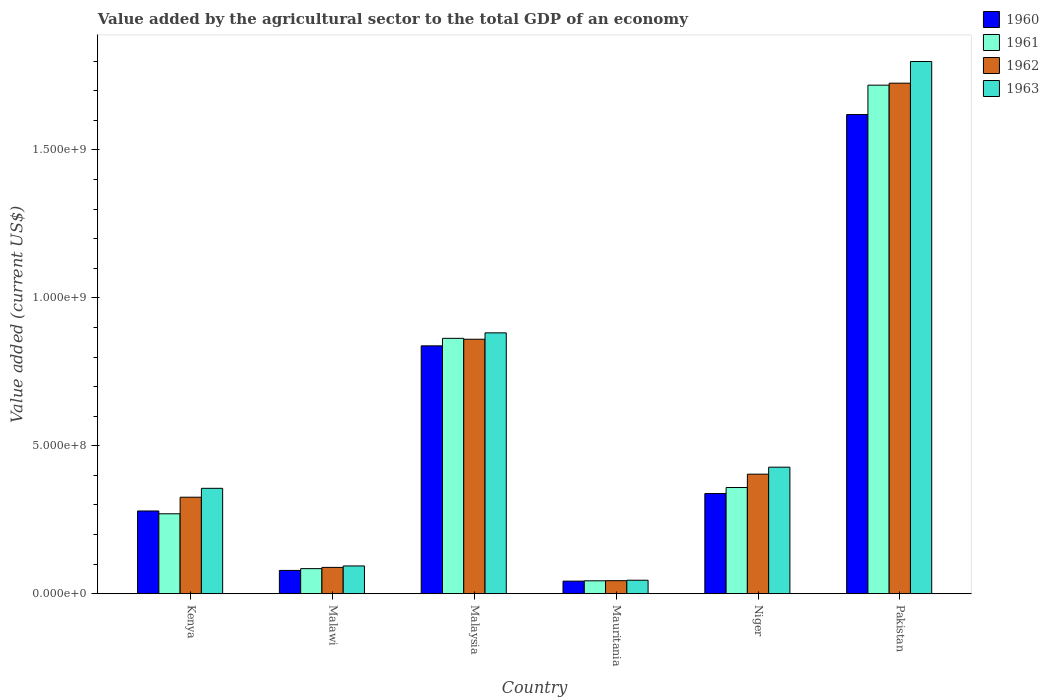How many groups of bars are there?
Your answer should be compact. 6. How many bars are there on the 6th tick from the left?
Provide a short and direct response. 4. What is the label of the 5th group of bars from the left?
Provide a short and direct response. Niger. In how many cases, is the number of bars for a given country not equal to the number of legend labels?
Your answer should be very brief. 0. What is the value added by the agricultural sector to the total GDP in 1960 in Malaysia?
Keep it short and to the point. 8.38e+08. Across all countries, what is the maximum value added by the agricultural sector to the total GDP in 1962?
Offer a terse response. 1.73e+09. Across all countries, what is the minimum value added by the agricultural sector to the total GDP in 1963?
Ensure brevity in your answer.  4.57e+07. In which country was the value added by the agricultural sector to the total GDP in 1962 minimum?
Provide a succinct answer. Mauritania. What is the total value added by the agricultural sector to the total GDP in 1963 in the graph?
Provide a succinct answer. 3.60e+09. What is the difference between the value added by the agricultural sector to the total GDP in 1963 in Kenya and that in Malaysia?
Your answer should be compact. -5.25e+08. What is the difference between the value added by the agricultural sector to the total GDP in 1963 in Malawi and the value added by the agricultural sector to the total GDP in 1961 in Malaysia?
Offer a very short reply. -7.69e+08. What is the average value added by the agricultural sector to the total GDP in 1962 per country?
Provide a succinct answer. 5.75e+08. What is the difference between the value added by the agricultural sector to the total GDP of/in 1963 and value added by the agricultural sector to the total GDP of/in 1961 in Niger?
Give a very brief answer. 6.88e+07. What is the ratio of the value added by the agricultural sector to the total GDP in 1960 in Malawi to that in Malaysia?
Ensure brevity in your answer.  0.09. Is the difference between the value added by the agricultural sector to the total GDP in 1963 in Kenya and Malaysia greater than the difference between the value added by the agricultural sector to the total GDP in 1961 in Kenya and Malaysia?
Offer a very short reply. Yes. What is the difference between the highest and the second highest value added by the agricultural sector to the total GDP in 1960?
Provide a short and direct response. -1.28e+09. What is the difference between the highest and the lowest value added by the agricultural sector to the total GDP in 1960?
Your answer should be compact. 1.58e+09. Is it the case that in every country, the sum of the value added by the agricultural sector to the total GDP in 1961 and value added by the agricultural sector to the total GDP in 1962 is greater than the sum of value added by the agricultural sector to the total GDP in 1963 and value added by the agricultural sector to the total GDP in 1960?
Your answer should be very brief. No. What does the 4th bar from the left in Mauritania represents?
Provide a short and direct response. 1963. What does the 1st bar from the right in Malaysia represents?
Your answer should be compact. 1963. Are the values on the major ticks of Y-axis written in scientific E-notation?
Keep it short and to the point. Yes. Does the graph contain any zero values?
Offer a terse response. No. Does the graph contain grids?
Offer a terse response. No. How many legend labels are there?
Your answer should be compact. 4. What is the title of the graph?
Make the answer very short. Value added by the agricultural sector to the total GDP of an economy. Does "1982" appear as one of the legend labels in the graph?
Ensure brevity in your answer.  No. What is the label or title of the X-axis?
Offer a very short reply. Country. What is the label or title of the Y-axis?
Give a very brief answer. Value added (current US$). What is the Value added (current US$) of 1960 in Kenya?
Give a very brief answer. 2.80e+08. What is the Value added (current US$) of 1961 in Kenya?
Offer a terse response. 2.70e+08. What is the Value added (current US$) in 1962 in Kenya?
Offer a terse response. 3.26e+08. What is the Value added (current US$) of 1963 in Kenya?
Offer a very short reply. 3.56e+08. What is the Value added (current US$) in 1960 in Malawi?
Offer a very short reply. 7.88e+07. What is the Value added (current US$) of 1961 in Malawi?
Ensure brevity in your answer.  8.48e+07. What is the Value added (current US$) in 1962 in Malawi?
Your answer should be compact. 8.90e+07. What is the Value added (current US$) in 1963 in Malawi?
Keep it short and to the point. 9.39e+07. What is the Value added (current US$) of 1960 in Malaysia?
Keep it short and to the point. 8.38e+08. What is the Value added (current US$) in 1961 in Malaysia?
Offer a very short reply. 8.63e+08. What is the Value added (current US$) in 1962 in Malaysia?
Your answer should be compact. 8.60e+08. What is the Value added (current US$) in 1963 in Malaysia?
Your response must be concise. 8.82e+08. What is the Value added (current US$) in 1960 in Mauritania?
Ensure brevity in your answer.  4.26e+07. What is the Value added (current US$) in 1961 in Mauritania?
Ensure brevity in your answer.  4.37e+07. What is the Value added (current US$) in 1962 in Mauritania?
Provide a short and direct response. 4.41e+07. What is the Value added (current US$) in 1963 in Mauritania?
Make the answer very short. 4.57e+07. What is the Value added (current US$) in 1960 in Niger?
Ensure brevity in your answer.  3.39e+08. What is the Value added (current US$) of 1961 in Niger?
Offer a very short reply. 3.59e+08. What is the Value added (current US$) of 1962 in Niger?
Provide a succinct answer. 4.04e+08. What is the Value added (current US$) of 1963 in Niger?
Offer a terse response. 4.28e+08. What is the Value added (current US$) in 1960 in Pakistan?
Your response must be concise. 1.62e+09. What is the Value added (current US$) in 1961 in Pakistan?
Your answer should be very brief. 1.72e+09. What is the Value added (current US$) in 1962 in Pakistan?
Offer a terse response. 1.73e+09. What is the Value added (current US$) in 1963 in Pakistan?
Ensure brevity in your answer.  1.80e+09. Across all countries, what is the maximum Value added (current US$) of 1960?
Provide a succinct answer. 1.62e+09. Across all countries, what is the maximum Value added (current US$) of 1961?
Make the answer very short. 1.72e+09. Across all countries, what is the maximum Value added (current US$) of 1962?
Your answer should be compact. 1.73e+09. Across all countries, what is the maximum Value added (current US$) in 1963?
Give a very brief answer. 1.80e+09. Across all countries, what is the minimum Value added (current US$) in 1960?
Provide a succinct answer. 4.26e+07. Across all countries, what is the minimum Value added (current US$) in 1961?
Offer a very short reply. 4.37e+07. Across all countries, what is the minimum Value added (current US$) of 1962?
Your answer should be compact. 4.41e+07. Across all countries, what is the minimum Value added (current US$) of 1963?
Your answer should be compact. 4.57e+07. What is the total Value added (current US$) in 1960 in the graph?
Your response must be concise. 3.20e+09. What is the total Value added (current US$) in 1961 in the graph?
Give a very brief answer. 3.34e+09. What is the total Value added (current US$) in 1962 in the graph?
Make the answer very short. 3.45e+09. What is the total Value added (current US$) of 1963 in the graph?
Ensure brevity in your answer.  3.60e+09. What is the difference between the Value added (current US$) in 1960 in Kenya and that in Malawi?
Your answer should be compact. 2.01e+08. What is the difference between the Value added (current US$) in 1961 in Kenya and that in Malawi?
Provide a succinct answer. 1.85e+08. What is the difference between the Value added (current US$) of 1962 in Kenya and that in Malawi?
Offer a very short reply. 2.37e+08. What is the difference between the Value added (current US$) in 1963 in Kenya and that in Malawi?
Your answer should be very brief. 2.62e+08. What is the difference between the Value added (current US$) in 1960 in Kenya and that in Malaysia?
Your answer should be very brief. -5.58e+08. What is the difference between the Value added (current US$) of 1961 in Kenya and that in Malaysia?
Keep it short and to the point. -5.93e+08. What is the difference between the Value added (current US$) in 1962 in Kenya and that in Malaysia?
Ensure brevity in your answer.  -5.34e+08. What is the difference between the Value added (current US$) of 1963 in Kenya and that in Malaysia?
Provide a short and direct response. -5.25e+08. What is the difference between the Value added (current US$) in 1960 in Kenya and that in Mauritania?
Make the answer very short. 2.37e+08. What is the difference between the Value added (current US$) in 1961 in Kenya and that in Mauritania?
Give a very brief answer. 2.26e+08. What is the difference between the Value added (current US$) of 1962 in Kenya and that in Mauritania?
Provide a succinct answer. 2.82e+08. What is the difference between the Value added (current US$) of 1963 in Kenya and that in Mauritania?
Your answer should be very brief. 3.11e+08. What is the difference between the Value added (current US$) in 1960 in Kenya and that in Niger?
Offer a terse response. -5.89e+07. What is the difference between the Value added (current US$) of 1961 in Kenya and that in Niger?
Offer a terse response. -8.87e+07. What is the difference between the Value added (current US$) of 1962 in Kenya and that in Niger?
Keep it short and to the point. -7.79e+07. What is the difference between the Value added (current US$) in 1963 in Kenya and that in Niger?
Make the answer very short. -7.14e+07. What is the difference between the Value added (current US$) of 1960 in Kenya and that in Pakistan?
Ensure brevity in your answer.  -1.34e+09. What is the difference between the Value added (current US$) in 1961 in Kenya and that in Pakistan?
Make the answer very short. -1.45e+09. What is the difference between the Value added (current US$) in 1962 in Kenya and that in Pakistan?
Your answer should be compact. -1.40e+09. What is the difference between the Value added (current US$) in 1963 in Kenya and that in Pakistan?
Give a very brief answer. -1.44e+09. What is the difference between the Value added (current US$) in 1960 in Malawi and that in Malaysia?
Offer a very short reply. -7.59e+08. What is the difference between the Value added (current US$) of 1961 in Malawi and that in Malaysia?
Offer a terse response. -7.78e+08. What is the difference between the Value added (current US$) in 1962 in Malawi and that in Malaysia?
Offer a very short reply. -7.71e+08. What is the difference between the Value added (current US$) in 1963 in Malawi and that in Malaysia?
Keep it short and to the point. -7.88e+08. What is the difference between the Value added (current US$) of 1960 in Malawi and that in Mauritania?
Provide a succinct answer. 3.62e+07. What is the difference between the Value added (current US$) in 1961 in Malawi and that in Mauritania?
Make the answer very short. 4.11e+07. What is the difference between the Value added (current US$) in 1962 in Malawi and that in Mauritania?
Your answer should be compact. 4.49e+07. What is the difference between the Value added (current US$) of 1963 in Malawi and that in Mauritania?
Make the answer very short. 4.83e+07. What is the difference between the Value added (current US$) in 1960 in Malawi and that in Niger?
Your answer should be very brief. -2.60e+08. What is the difference between the Value added (current US$) of 1961 in Malawi and that in Niger?
Give a very brief answer. -2.74e+08. What is the difference between the Value added (current US$) in 1962 in Malawi and that in Niger?
Your answer should be compact. -3.15e+08. What is the difference between the Value added (current US$) of 1963 in Malawi and that in Niger?
Provide a short and direct response. -3.34e+08. What is the difference between the Value added (current US$) in 1960 in Malawi and that in Pakistan?
Make the answer very short. -1.54e+09. What is the difference between the Value added (current US$) in 1961 in Malawi and that in Pakistan?
Offer a terse response. -1.63e+09. What is the difference between the Value added (current US$) in 1962 in Malawi and that in Pakistan?
Ensure brevity in your answer.  -1.64e+09. What is the difference between the Value added (current US$) in 1963 in Malawi and that in Pakistan?
Provide a succinct answer. -1.70e+09. What is the difference between the Value added (current US$) of 1960 in Malaysia and that in Mauritania?
Your answer should be compact. 7.95e+08. What is the difference between the Value added (current US$) in 1961 in Malaysia and that in Mauritania?
Your answer should be very brief. 8.19e+08. What is the difference between the Value added (current US$) in 1962 in Malaysia and that in Mauritania?
Your response must be concise. 8.16e+08. What is the difference between the Value added (current US$) in 1963 in Malaysia and that in Mauritania?
Your response must be concise. 8.36e+08. What is the difference between the Value added (current US$) of 1960 in Malaysia and that in Niger?
Keep it short and to the point. 4.99e+08. What is the difference between the Value added (current US$) in 1961 in Malaysia and that in Niger?
Your response must be concise. 5.04e+08. What is the difference between the Value added (current US$) of 1962 in Malaysia and that in Niger?
Your answer should be compact. 4.56e+08. What is the difference between the Value added (current US$) of 1963 in Malaysia and that in Niger?
Offer a very short reply. 4.54e+08. What is the difference between the Value added (current US$) of 1960 in Malaysia and that in Pakistan?
Your answer should be very brief. -7.82e+08. What is the difference between the Value added (current US$) in 1961 in Malaysia and that in Pakistan?
Provide a short and direct response. -8.56e+08. What is the difference between the Value added (current US$) in 1962 in Malaysia and that in Pakistan?
Your answer should be compact. -8.65e+08. What is the difference between the Value added (current US$) of 1963 in Malaysia and that in Pakistan?
Keep it short and to the point. -9.17e+08. What is the difference between the Value added (current US$) of 1960 in Mauritania and that in Niger?
Provide a succinct answer. -2.96e+08. What is the difference between the Value added (current US$) of 1961 in Mauritania and that in Niger?
Ensure brevity in your answer.  -3.15e+08. What is the difference between the Value added (current US$) in 1962 in Mauritania and that in Niger?
Give a very brief answer. -3.60e+08. What is the difference between the Value added (current US$) in 1963 in Mauritania and that in Niger?
Provide a short and direct response. -3.82e+08. What is the difference between the Value added (current US$) of 1960 in Mauritania and that in Pakistan?
Your response must be concise. -1.58e+09. What is the difference between the Value added (current US$) of 1961 in Mauritania and that in Pakistan?
Offer a very short reply. -1.67e+09. What is the difference between the Value added (current US$) in 1962 in Mauritania and that in Pakistan?
Make the answer very short. -1.68e+09. What is the difference between the Value added (current US$) of 1963 in Mauritania and that in Pakistan?
Give a very brief answer. -1.75e+09. What is the difference between the Value added (current US$) of 1960 in Niger and that in Pakistan?
Ensure brevity in your answer.  -1.28e+09. What is the difference between the Value added (current US$) of 1961 in Niger and that in Pakistan?
Offer a very short reply. -1.36e+09. What is the difference between the Value added (current US$) of 1962 in Niger and that in Pakistan?
Provide a succinct answer. -1.32e+09. What is the difference between the Value added (current US$) of 1963 in Niger and that in Pakistan?
Make the answer very short. -1.37e+09. What is the difference between the Value added (current US$) in 1960 in Kenya and the Value added (current US$) in 1961 in Malawi?
Your answer should be very brief. 1.95e+08. What is the difference between the Value added (current US$) in 1960 in Kenya and the Value added (current US$) in 1962 in Malawi?
Your answer should be compact. 1.91e+08. What is the difference between the Value added (current US$) in 1960 in Kenya and the Value added (current US$) in 1963 in Malawi?
Your answer should be very brief. 1.86e+08. What is the difference between the Value added (current US$) in 1961 in Kenya and the Value added (current US$) in 1962 in Malawi?
Offer a terse response. 1.81e+08. What is the difference between the Value added (current US$) in 1961 in Kenya and the Value added (current US$) in 1963 in Malawi?
Give a very brief answer. 1.76e+08. What is the difference between the Value added (current US$) in 1962 in Kenya and the Value added (current US$) in 1963 in Malawi?
Offer a terse response. 2.32e+08. What is the difference between the Value added (current US$) in 1960 in Kenya and the Value added (current US$) in 1961 in Malaysia?
Provide a short and direct response. -5.83e+08. What is the difference between the Value added (current US$) in 1960 in Kenya and the Value added (current US$) in 1962 in Malaysia?
Your answer should be very brief. -5.80e+08. What is the difference between the Value added (current US$) in 1960 in Kenya and the Value added (current US$) in 1963 in Malaysia?
Give a very brief answer. -6.02e+08. What is the difference between the Value added (current US$) of 1961 in Kenya and the Value added (current US$) of 1962 in Malaysia?
Keep it short and to the point. -5.90e+08. What is the difference between the Value added (current US$) in 1961 in Kenya and the Value added (current US$) in 1963 in Malaysia?
Offer a very short reply. -6.11e+08. What is the difference between the Value added (current US$) in 1962 in Kenya and the Value added (current US$) in 1963 in Malaysia?
Provide a short and direct response. -5.55e+08. What is the difference between the Value added (current US$) in 1960 in Kenya and the Value added (current US$) in 1961 in Mauritania?
Ensure brevity in your answer.  2.36e+08. What is the difference between the Value added (current US$) of 1960 in Kenya and the Value added (current US$) of 1962 in Mauritania?
Offer a terse response. 2.36e+08. What is the difference between the Value added (current US$) of 1960 in Kenya and the Value added (current US$) of 1963 in Mauritania?
Give a very brief answer. 2.34e+08. What is the difference between the Value added (current US$) of 1961 in Kenya and the Value added (current US$) of 1962 in Mauritania?
Your answer should be very brief. 2.26e+08. What is the difference between the Value added (current US$) in 1961 in Kenya and the Value added (current US$) in 1963 in Mauritania?
Ensure brevity in your answer.  2.25e+08. What is the difference between the Value added (current US$) of 1962 in Kenya and the Value added (current US$) of 1963 in Mauritania?
Offer a terse response. 2.81e+08. What is the difference between the Value added (current US$) in 1960 in Kenya and the Value added (current US$) in 1961 in Niger?
Offer a very short reply. -7.92e+07. What is the difference between the Value added (current US$) of 1960 in Kenya and the Value added (current US$) of 1962 in Niger?
Offer a terse response. -1.24e+08. What is the difference between the Value added (current US$) of 1960 in Kenya and the Value added (current US$) of 1963 in Niger?
Your answer should be very brief. -1.48e+08. What is the difference between the Value added (current US$) in 1961 in Kenya and the Value added (current US$) in 1962 in Niger?
Provide a short and direct response. -1.34e+08. What is the difference between the Value added (current US$) of 1961 in Kenya and the Value added (current US$) of 1963 in Niger?
Keep it short and to the point. -1.58e+08. What is the difference between the Value added (current US$) in 1962 in Kenya and the Value added (current US$) in 1963 in Niger?
Your answer should be very brief. -1.02e+08. What is the difference between the Value added (current US$) of 1960 in Kenya and the Value added (current US$) of 1961 in Pakistan?
Your answer should be compact. -1.44e+09. What is the difference between the Value added (current US$) in 1960 in Kenya and the Value added (current US$) in 1962 in Pakistan?
Give a very brief answer. -1.45e+09. What is the difference between the Value added (current US$) of 1960 in Kenya and the Value added (current US$) of 1963 in Pakistan?
Keep it short and to the point. -1.52e+09. What is the difference between the Value added (current US$) in 1961 in Kenya and the Value added (current US$) in 1962 in Pakistan?
Your answer should be very brief. -1.46e+09. What is the difference between the Value added (current US$) in 1961 in Kenya and the Value added (current US$) in 1963 in Pakistan?
Your answer should be very brief. -1.53e+09. What is the difference between the Value added (current US$) in 1962 in Kenya and the Value added (current US$) in 1963 in Pakistan?
Make the answer very short. -1.47e+09. What is the difference between the Value added (current US$) of 1960 in Malawi and the Value added (current US$) of 1961 in Malaysia?
Ensure brevity in your answer.  -7.84e+08. What is the difference between the Value added (current US$) of 1960 in Malawi and the Value added (current US$) of 1962 in Malaysia?
Provide a short and direct response. -7.81e+08. What is the difference between the Value added (current US$) of 1960 in Malawi and the Value added (current US$) of 1963 in Malaysia?
Keep it short and to the point. -8.03e+08. What is the difference between the Value added (current US$) in 1961 in Malawi and the Value added (current US$) in 1962 in Malaysia?
Your answer should be very brief. -7.75e+08. What is the difference between the Value added (current US$) in 1961 in Malawi and the Value added (current US$) in 1963 in Malaysia?
Provide a succinct answer. -7.97e+08. What is the difference between the Value added (current US$) in 1962 in Malawi and the Value added (current US$) in 1963 in Malaysia?
Give a very brief answer. -7.93e+08. What is the difference between the Value added (current US$) of 1960 in Malawi and the Value added (current US$) of 1961 in Mauritania?
Provide a succinct answer. 3.51e+07. What is the difference between the Value added (current US$) in 1960 in Malawi and the Value added (current US$) in 1962 in Mauritania?
Your answer should be very brief. 3.47e+07. What is the difference between the Value added (current US$) in 1960 in Malawi and the Value added (current US$) in 1963 in Mauritania?
Offer a very short reply. 3.32e+07. What is the difference between the Value added (current US$) of 1961 in Malawi and the Value added (current US$) of 1962 in Mauritania?
Your response must be concise. 4.07e+07. What is the difference between the Value added (current US$) in 1961 in Malawi and the Value added (current US$) in 1963 in Mauritania?
Offer a terse response. 3.92e+07. What is the difference between the Value added (current US$) in 1962 in Malawi and the Value added (current US$) in 1963 in Mauritania?
Your answer should be compact. 4.34e+07. What is the difference between the Value added (current US$) of 1960 in Malawi and the Value added (current US$) of 1961 in Niger?
Make the answer very short. -2.80e+08. What is the difference between the Value added (current US$) in 1960 in Malawi and the Value added (current US$) in 1962 in Niger?
Keep it short and to the point. -3.25e+08. What is the difference between the Value added (current US$) of 1960 in Malawi and the Value added (current US$) of 1963 in Niger?
Provide a short and direct response. -3.49e+08. What is the difference between the Value added (current US$) of 1961 in Malawi and the Value added (current US$) of 1962 in Niger?
Provide a short and direct response. -3.19e+08. What is the difference between the Value added (current US$) in 1961 in Malawi and the Value added (current US$) in 1963 in Niger?
Provide a succinct answer. -3.43e+08. What is the difference between the Value added (current US$) in 1962 in Malawi and the Value added (current US$) in 1963 in Niger?
Provide a succinct answer. -3.39e+08. What is the difference between the Value added (current US$) of 1960 in Malawi and the Value added (current US$) of 1961 in Pakistan?
Provide a succinct answer. -1.64e+09. What is the difference between the Value added (current US$) in 1960 in Malawi and the Value added (current US$) in 1962 in Pakistan?
Offer a very short reply. -1.65e+09. What is the difference between the Value added (current US$) in 1960 in Malawi and the Value added (current US$) in 1963 in Pakistan?
Offer a terse response. -1.72e+09. What is the difference between the Value added (current US$) in 1961 in Malawi and the Value added (current US$) in 1962 in Pakistan?
Your answer should be very brief. -1.64e+09. What is the difference between the Value added (current US$) of 1961 in Malawi and the Value added (current US$) of 1963 in Pakistan?
Your response must be concise. -1.71e+09. What is the difference between the Value added (current US$) in 1962 in Malawi and the Value added (current US$) in 1963 in Pakistan?
Provide a succinct answer. -1.71e+09. What is the difference between the Value added (current US$) in 1960 in Malaysia and the Value added (current US$) in 1961 in Mauritania?
Your response must be concise. 7.94e+08. What is the difference between the Value added (current US$) of 1960 in Malaysia and the Value added (current US$) of 1962 in Mauritania?
Make the answer very short. 7.94e+08. What is the difference between the Value added (current US$) in 1960 in Malaysia and the Value added (current US$) in 1963 in Mauritania?
Provide a succinct answer. 7.92e+08. What is the difference between the Value added (current US$) of 1961 in Malaysia and the Value added (current US$) of 1962 in Mauritania?
Provide a short and direct response. 8.19e+08. What is the difference between the Value added (current US$) of 1961 in Malaysia and the Value added (current US$) of 1963 in Mauritania?
Give a very brief answer. 8.17e+08. What is the difference between the Value added (current US$) of 1962 in Malaysia and the Value added (current US$) of 1963 in Mauritania?
Ensure brevity in your answer.  8.14e+08. What is the difference between the Value added (current US$) in 1960 in Malaysia and the Value added (current US$) in 1961 in Niger?
Make the answer very short. 4.79e+08. What is the difference between the Value added (current US$) of 1960 in Malaysia and the Value added (current US$) of 1962 in Niger?
Keep it short and to the point. 4.34e+08. What is the difference between the Value added (current US$) in 1960 in Malaysia and the Value added (current US$) in 1963 in Niger?
Your answer should be very brief. 4.10e+08. What is the difference between the Value added (current US$) in 1961 in Malaysia and the Value added (current US$) in 1962 in Niger?
Your answer should be compact. 4.59e+08. What is the difference between the Value added (current US$) of 1961 in Malaysia and the Value added (current US$) of 1963 in Niger?
Ensure brevity in your answer.  4.35e+08. What is the difference between the Value added (current US$) of 1962 in Malaysia and the Value added (current US$) of 1963 in Niger?
Offer a very short reply. 4.32e+08. What is the difference between the Value added (current US$) in 1960 in Malaysia and the Value added (current US$) in 1961 in Pakistan?
Your response must be concise. -8.81e+08. What is the difference between the Value added (current US$) of 1960 in Malaysia and the Value added (current US$) of 1962 in Pakistan?
Ensure brevity in your answer.  -8.88e+08. What is the difference between the Value added (current US$) in 1960 in Malaysia and the Value added (current US$) in 1963 in Pakistan?
Provide a short and direct response. -9.61e+08. What is the difference between the Value added (current US$) of 1961 in Malaysia and the Value added (current US$) of 1962 in Pakistan?
Keep it short and to the point. -8.62e+08. What is the difference between the Value added (current US$) in 1961 in Malaysia and the Value added (current US$) in 1963 in Pakistan?
Offer a very short reply. -9.36e+08. What is the difference between the Value added (current US$) of 1962 in Malaysia and the Value added (current US$) of 1963 in Pakistan?
Ensure brevity in your answer.  -9.39e+08. What is the difference between the Value added (current US$) of 1960 in Mauritania and the Value added (current US$) of 1961 in Niger?
Ensure brevity in your answer.  -3.16e+08. What is the difference between the Value added (current US$) of 1960 in Mauritania and the Value added (current US$) of 1962 in Niger?
Your response must be concise. -3.62e+08. What is the difference between the Value added (current US$) in 1960 in Mauritania and the Value added (current US$) in 1963 in Niger?
Your response must be concise. -3.85e+08. What is the difference between the Value added (current US$) in 1961 in Mauritania and the Value added (current US$) in 1962 in Niger?
Your response must be concise. -3.60e+08. What is the difference between the Value added (current US$) of 1961 in Mauritania and the Value added (current US$) of 1963 in Niger?
Keep it short and to the point. -3.84e+08. What is the difference between the Value added (current US$) in 1962 in Mauritania and the Value added (current US$) in 1963 in Niger?
Your response must be concise. -3.84e+08. What is the difference between the Value added (current US$) of 1960 in Mauritania and the Value added (current US$) of 1961 in Pakistan?
Provide a succinct answer. -1.68e+09. What is the difference between the Value added (current US$) in 1960 in Mauritania and the Value added (current US$) in 1962 in Pakistan?
Keep it short and to the point. -1.68e+09. What is the difference between the Value added (current US$) of 1960 in Mauritania and the Value added (current US$) of 1963 in Pakistan?
Keep it short and to the point. -1.76e+09. What is the difference between the Value added (current US$) of 1961 in Mauritania and the Value added (current US$) of 1962 in Pakistan?
Provide a short and direct response. -1.68e+09. What is the difference between the Value added (current US$) of 1961 in Mauritania and the Value added (current US$) of 1963 in Pakistan?
Your response must be concise. -1.75e+09. What is the difference between the Value added (current US$) in 1962 in Mauritania and the Value added (current US$) in 1963 in Pakistan?
Make the answer very short. -1.75e+09. What is the difference between the Value added (current US$) of 1960 in Niger and the Value added (current US$) of 1961 in Pakistan?
Provide a short and direct response. -1.38e+09. What is the difference between the Value added (current US$) of 1960 in Niger and the Value added (current US$) of 1962 in Pakistan?
Provide a short and direct response. -1.39e+09. What is the difference between the Value added (current US$) of 1960 in Niger and the Value added (current US$) of 1963 in Pakistan?
Make the answer very short. -1.46e+09. What is the difference between the Value added (current US$) of 1961 in Niger and the Value added (current US$) of 1962 in Pakistan?
Your answer should be compact. -1.37e+09. What is the difference between the Value added (current US$) of 1961 in Niger and the Value added (current US$) of 1963 in Pakistan?
Offer a very short reply. -1.44e+09. What is the difference between the Value added (current US$) of 1962 in Niger and the Value added (current US$) of 1963 in Pakistan?
Provide a short and direct response. -1.39e+09. What is the average Value added (current US$) of 1960 per country?
Ensure brevity in your answer.  5.33e+08. What is the average Value added (current US$) of 1961 per country?
Your answer should be very brief. 5.57e+08. What is the average Value added (current US$) in 1962 per country?
Ensure brevity in your answer.  5.75e+08. What is the average Value added (current US$) of 1963 per country?
Keep it short and to the point. 6.01e+08. What is the difference between the Value added (current US$) of 1960 and Value added (current US$) of 1961 in Kenya?
Provide a succinct answer. 9.51e+06. What is the difference between the Value added (current US$) in 1960 and Value added (current US$) in 1962 in Kenya?
Your answer should be compact. -4.65e+07. What is the difference between the Value added (current US$) of 1960 and Value added (current US$) of 1963 in Kenya?
Your answer should be very brief. -7.66e+07. What is the difference between the Value added (current US$) in 1961 and Value added (current US$) in 1962 in Kenya?
Your answer should be compact. -5.60e+07. What is the difference between the Value added (current US$) in 1961 and Value added (current US$) in 1963 in Kenya?
Ensure brevity in your answer.  -8.61e+07. What is the difference between the Value added (current US$) of 1962 and Value added (current US$) of 1963 in Kenya?
Offer a very short reply. -3.01e+07. What is the difference between the Value added (current US$) in 1960 and Value added (current US$) in 1961 in Malawi?
Offer a terse response. -6.02e+06. What is the difference between the Value added (current US$) in 1960 and Value added (current US$) in 1962 in Malawi?
Make the answer very short. -1.02e+07. What is the difference between the Value added (current US$) in 1960 and Value added (current US$) in 1963 in Malawi?
Provide a succinct answer. -1.51e+07. What is the difference between the Value added (current US$) in 1961 and Value added (current US$) in 1962 in Malawi?
Offer a very short reply. -4.20e+06. What is the difference between the Value added (current US$) in 1961 and Value added (current US$) in 1963 in Malawi?
Offer a terse response. -9.10e+06. What is the difference between the Value added (current US$) of 1962 and Value added (current US$) of 1963 in Malawi?
Make the answer very short. -4.90e+06. What is the difference between the Value added (current US$) in 1960 and Value added (current US$) in 1961 in Malaysia?
Ensure brevity in your answer.  -2.54e+07. What is the difference between the Value added (current US$) of 1960 and Value added (current US$) of 1962 in Malaysia?
Offer a very short reply. -2.23e+07. What is the difference between the Value added (current US$) of 1960 and Value added (current US$) of 1963 in Malaysia?
Give a very brief answer. -4.39e+07. What is the difference between the Value added (current US$) of 1961 and Value added (current US$) of 1962 in Malaysia?
Your answer should be compact. 3.09e+06. What is the difference between the Value added (current US$) of 1961 and Value added (current US$) of 1963 in Malaysia?
Ensure brevity in your answer.  -1.85e+07. What is the difference between the Value added (current US$) in 1962 and Value added (current US$) in 1963 in Malaysia?
Offer a very short reply. -2.16e+07. What is the difference between the Value added (current US$) of 1960 and Value added (current US$) of 1961 in Mauritania?
Your answer should be very brief. -1.15e+06. What is the difference between the Value added (current US$) of 1960 and Value added (current US$) of 1962 in Mauritania?
Provide a short and direct response. -1.54e+06. What is the difference between the Value added (current US$) of 1960 and Value added (current US$) of 1963 in Mauritania?
Your response must be concise. -3.07e+06. What is the difference between the Value added (current US$) of 1961 and Value added (current US$) of 1962 in Mauritania?
Your answer should be compact. -3.84e+05. What is the difference between the Value added (current US$) in 1961 and Value added (current US$) in 1963 in Mauritania?
Give a very brief answer. -1.92e+06. What is the difference between the Value added (current US$) of 1962 and Value added (current US$) of 1963 in Mauritania?
Offer a very short reply. -1.54e+06. What is the difference between the Value added (current US$) of 1960 and Value added (current US$) of 1961 in Niger?
Your answer should be compact. -2.03e+07. What is the difference between the Value added (current US$) of 1960 and Value added (current US$) of 1962 in Niger?
Your answer should be compact. -6.55e+07. What is the difference between the Value added (current US$) of 1960 and Value added (current US$) of 1963 in Niger?
Give a very brief answer. -8.91e+07. What is the difference between the Value added (current US$) in 1961 and Value added (current US$) in 1962 in Niger?
Offer a very short reply. -4.52e+07. What is the difference between the Value added (current US$) of 1961 and Value added (current US$) of 1963 in Niger?
Make the answer very short. -6.88e+07. What is the difference between the Value added (current US$) of 1962 and Value added (current US$) of 1963 in Niger?
Your answer should be compact. -2.36e+07. What is the difference between the Value added (current US$) in 1960 and Value added (current US$) in 1961 in Pakistan?
Give a very brief answer. -9.93e+07. What is the difference between the Value added (current US$) of 1960 and Value added (current US$) of 1962 in Pakistan?
Make the answer very short. -1.06e+08. What is the difference between the Value added (current US$) in 1960 and Value added (current US$) in 1963 in Pakistan?
Provide a succinct answer. -1.79e+08. What is the difference between the Value added (current US$) in 1961 and Value added (current US$) in 1962 in Pakistan?
Your answer should be very brief. -6.72e+06. What is the difference between the Value added (current US$) in 1961 and Value added (current US$) in 1963 in Pakistan?
Your answer should be very brief. -8.00e+07. What is the difference between the Value added (current US$) of 1962 and Value added (current US$) of 1963 in Pakistan?
Ensure brevity in your answer.  -7.33e+07. What is the ratio of the Value added (current US$) in 1960 in Kenya to that in Malawi?
Ensure brevity in your answer.  3.55. What is the ratio of the Value added (current US$) of 1961 in Kenya to that in Malawi?
Keep it short and to the point. 3.18. What is the ratio of the Value added (current US$) in 1962 in Kenya to that in Malawi?
Provide a succinct answer. 3.66. What is the ratio of the Value added (current US$) of 1963 in Kenya to that in Malawi?
Keep it short and to the point. 3.79. What is the ratio of the Value added (current US$) of 1960 in Kenya to that in Malaysia?
Your response must be concise. 0.33. What is the ratio of the Value added (current US$) in 1961 in Kenya to that in Malaysia?
Your response must be concise. 0.31. What is the ratio of the Value added (current US$) of 1962 in Kenya to that in Malaysia?
Provide a short and direct response. 0.38. What is the ratio of the Value added (current US$) of 1963 in Kenya to that in Malaysia?
Keep it short and to the point. 0.4. What is the ratio of the Value added (current US$) in 1960 in Kenya to that in Mauritania?
Offer a terse response. 6.57. What is the ratio of the Value added (current US$) of 1961 in Kenya to that in Mauritania?
Offer a very short reply. 6.18. What is the ratio of the Value added (current US$) of 1962 in Kenya to that in Mauritania?
Your answer should be very brief. 7.39. What is the ratio of the Value added (current US$) of 1963 in Kenya to that in Mauritania?
Provide a short and direct response. 7.8. What is the ratio of the Value added (current US$) of 1960 in Kenya to that in Niger?
Make the answer very short. 0.83. What is the ratio of the Value added (current US$) of 1961 in Kenya to that in Niger?
Give a very brief answer. 0.75. What is the ratio of the Value added (current US$) in 1962 in Kenya to that in Niger?
Offer a very short reply. 0.81. What is the ratio of the Value added (current US$) in 1963 in Kenya to that in Niger?
Ensure brevity in your answer.  0.83. What is the ratio of the Value added (current US$) in 1960 in Kenya to that in Pakistan?
Your answer should be very brief. 0.17. What is the ratio of the Value added (current US$) in 1961 in Kenya to that in Pakistan?
Your response must be concise. 0.16. What is the ratio of the Value added (current US$) in 1962 in Kenya to that in Pakistan?
Ensure brevity in your answer.  0.19. What is the ratio of the Value added (current US$) of 1963 in Kenya to that in Pakistan?
Your response must be concise. 0.2. What is the ratio of the Value added (current US$) in 1960 in Malawi to that in Malaysia?
Your answer should be very brief. 0.09. What is the ratio of the Value added (current US$) of 1961 in Malawi to that in Malaysia?
Make the answer very short. 0.1. What is the ratio of the Value added (current US$) in 1962 in Malawi to that in Malaysia?
Provide a short and direct response. 0.1. What is the ratio of the Value added (current US$) in 1963 in Malawi to that in Malaysia?
Your response must be concise. 0.11. What is the ratio of the Value added (current US$) of 1960 in Malawi to that in Mauritania?
Offer a very short reply. 1.85. What is the ratio of the Value added (current US$) in 1961 in Malawi to that in Mauritania?
Your answer should be compact. 1.94. What is the ratio of the Value added (current US$) in 1962 in Malawi to that in Mauritania?
Offer a terse response. 2.02. What is the ratio of the Value added (current US$) of 1963 in Malawi to that in Mauritania?
Offer a very short reply. 2.06. What is the ratio of the Value added (current US$) of 1960 in Malawi to that in Niger?
Ensure brevity in your answer.  0.23. What is the ratio of the Value added (current US$) of 1961 in Malawi to that in Niger?
Your response must be concise. 0.24. What is the ratio of the Value added (current US$) in 1962 in Malawi to that in Niger?
Ensure brevity in your answer.  0.22. What is the ratio of the Value added (current US$) in 1963 in Malawi to that in Niger?
Keep it short and to the point. 0.22. What is the ratio of the Value added (current US$) in 1960 in Malawi to that in Pakistan?
Your answer should be very brief. 0.05. What is the ratio of the Value added (current US$) of 1961 in Malawi to that in Pakistan?
Offer a terse response. 0.05. What is the ratio of the Value added (current US$) of 1962 in Malawi to that in Pakistan?
Your answer should be compact. 0.05. What is the ratio of the Value added (current US$) of 1963 in Malawi to that in Pakistan?
Your answer should be compact. 0.05. What is the ratio of the Value added (current US$) in 1960 in Malaysia to that in Mauritania?
Your answer should be compact. 19.67. What is the ratio of the Value added (current US$) of 1961 in Malaysia to that in Mauritania?
Keep it short and to the point. 19.73. What is the ratio of the Value added (current US$) in 1962 in Malaysia to that in Mauritania?
Ensure brevity in your answer.  19.49. What is the ratio of the Value added (current US$) in 1963 in Malaysia to that in Mauritania?
Provide a succinct answer. 19.31. What is the ratio of the Value added (current US$) in 1960 in Malaysia to that in Niger?
Offer a very short reply. 2.47. What is the ratio of the Value added (current US$) in 1961 in Malaysia to that in Niger?
Offer a very short reply. 2.4. What is the ratio of the Value added (current US$) of 1962 in Malaysia to that in Niger?
Give a very brief answer. 2.13. What is the ratio of the Value added (current US$) in 1963 in Malaysia to that in Niger?
Keep it short and to the point. 2.06. What is the ratio of the Value added (current US$) in 1960 in Malaysia to that in Pakistan?
Your response must be concise. 0.52. What is the ratio of the Value added (current US$) in 1961 in Malaysia to that in Pakistan?
Provide a short and direct response. 0.5. What is the ratio of the Value added (current US$) of 1962 in Malaysia to that in Pakistan?
Offer a terse response. 0.5. What is the ratio of the Value added (current US$) of 1963 in Malaysia to that in Pakistan?
Provide a succinct answer. 0.49. What is the ratio of the Value added (current US$) of 1960 in Mauritania to that in Niger?
Your answer should be very brief. 0.13. What is the ratio of the Value added (current US$) of 1961 in Mauritania to that in Niger?
Provide a succinct answer. 0.12. What is the ratio of the Value added (current US$) in 1962 in Mauritania to that in Niger?
Offer a terse response. 0.11. What is the ratio of the Value added (current US$) of 1963 in Mauritania to that in Niger?
Offer a terse response. 0.11. What is the ratio of the Value added (current US$) in 1960 in Mauritania to that in Pakistan?
Offer a terse response. 0.03. What is the ratio of the Value added (current US$) of 1961 in Mauritania to that in Pakistan?
Provide a short and direct response. 0.03. What is the ratio of the Value added (current US$) in 1962 in Mauritania to that in Pakistan?
Provide a short and direct response. 0.03. What is the ratio of the Value added (current US$) of 1963 in Mauritania to that in Pakistan?
Give a very brief answer. 0.03. What is the ratio of the Value added (current US$) of 1960 in Niger to that in Pakistan?
Make the answer very short. 0.21. What is the ratio of the Value added (current US$) in 1961 in Niger to that in Pakistan?
Your response must be concise. 0.21. What is the ratio of the Value added (current US$) in 1962 in Niger to that in Pakistan?
Provide a short and direct response. 0.23. What is the ratio of the Value added (current US$) in 1963 in Niger to that in Pakistan?
Your answer should be compact. 0.24. What is the difference between the highest and the second highest Value added (current US$) in 1960?
Provide a succinct answer. 7.82e+08. What is the difference between the highest and the second highest Value added (current US$) of 1961?
Provide a short and direct response. 8.56e+08. What is the difference between the highest and the second highest Value added (current US$) in 1962?
Provide a succinct answer. 8.65e+08. What is the difference between the highest and the second highest Value added (current US$) in 1963?
Provide a succinct answer. 9.17e+08. What is the difference between the highest and the lowest Value added (current US$) of 1960?
Keep it short and to the point. 1.58e+09. What is the difference between the highest and the lowest Value added (current US$) of 1961?
Your answer should be very brief. 1.67e+09. What is the difference between the highest and the lowest Value added (current US$) of 1962?
Give a very brief answer. 1.68e+09. What is the difference between the highest and the lowest Value added (current US$) of 1963?
Offer a very short reply. 1.75e+09. 